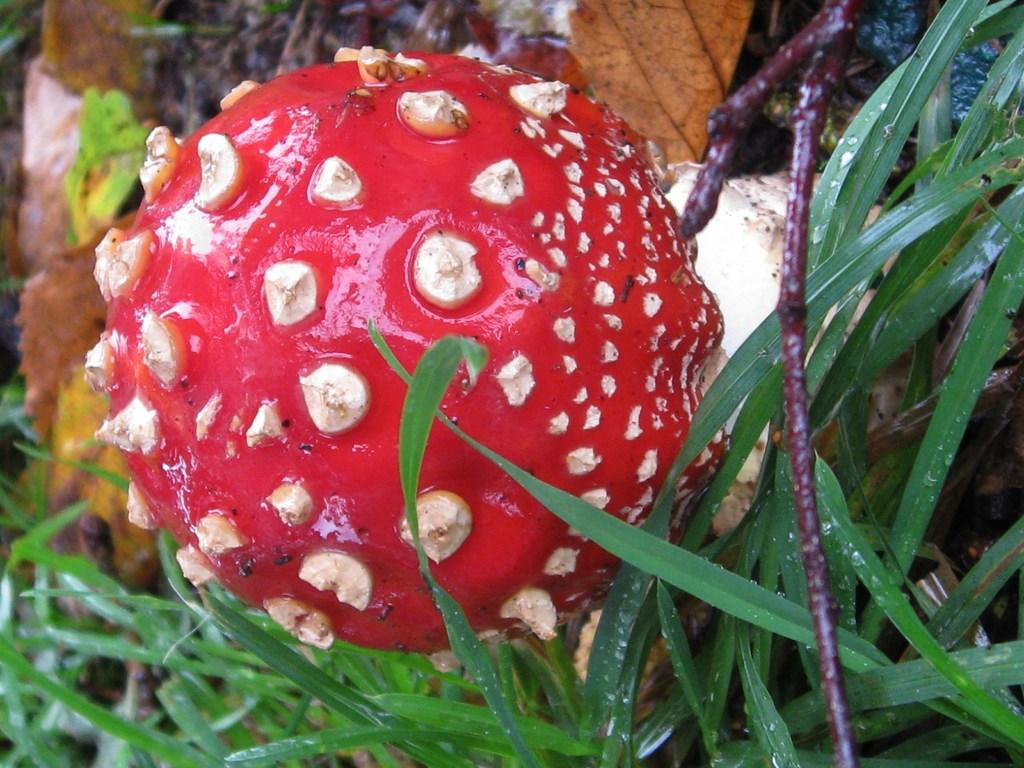What color of the fruit in the image? The fruit in the image is red. What type of vegetation can be seen in the image? There is grass visible in the image. How many cars are parked on the grass in the image? There are no cars present in the image; it only features a red fruit and grass. Is there a laborer carrying a carriage in the image? There is no laborer or carriage present in the image. 